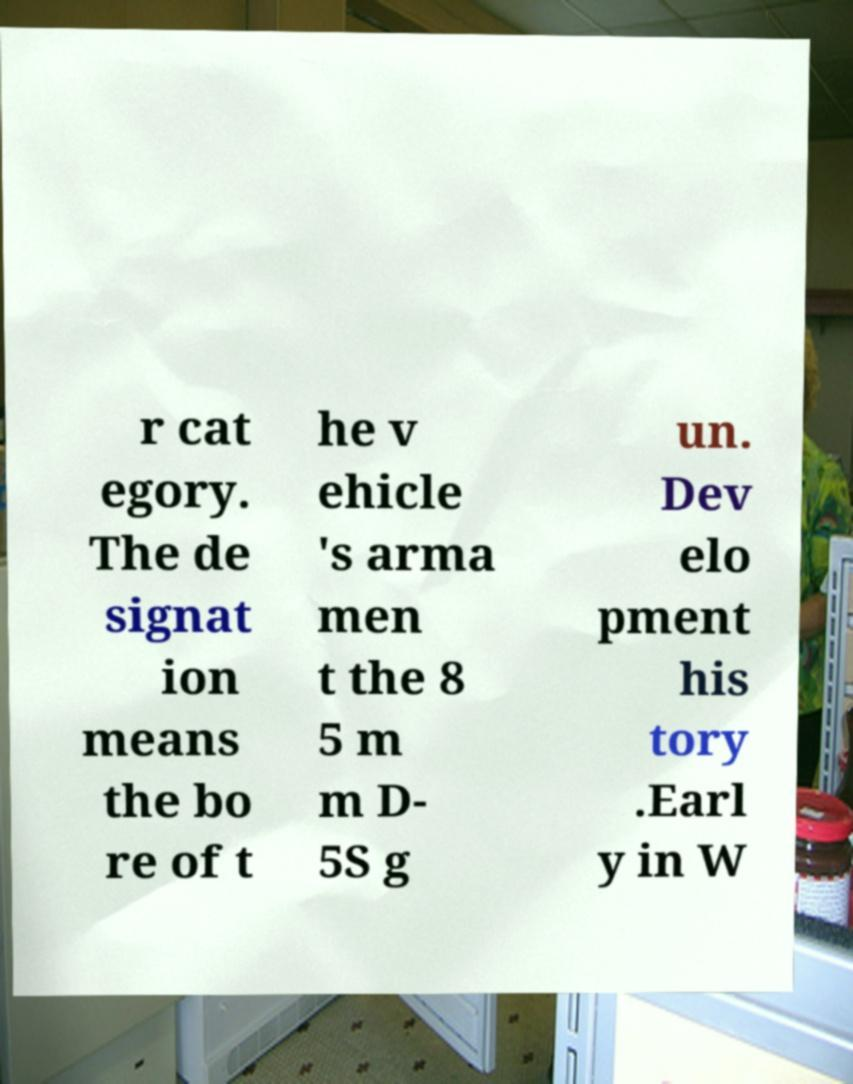For documentation purposes, I need the text within this image transcribed. Could you provide that? r cat egory. The de signat ion means the bo re of t he v ehicle 's arma men t the 8 5 m m D- 5S g un. Dev elo pment his tory .Earl y in W 